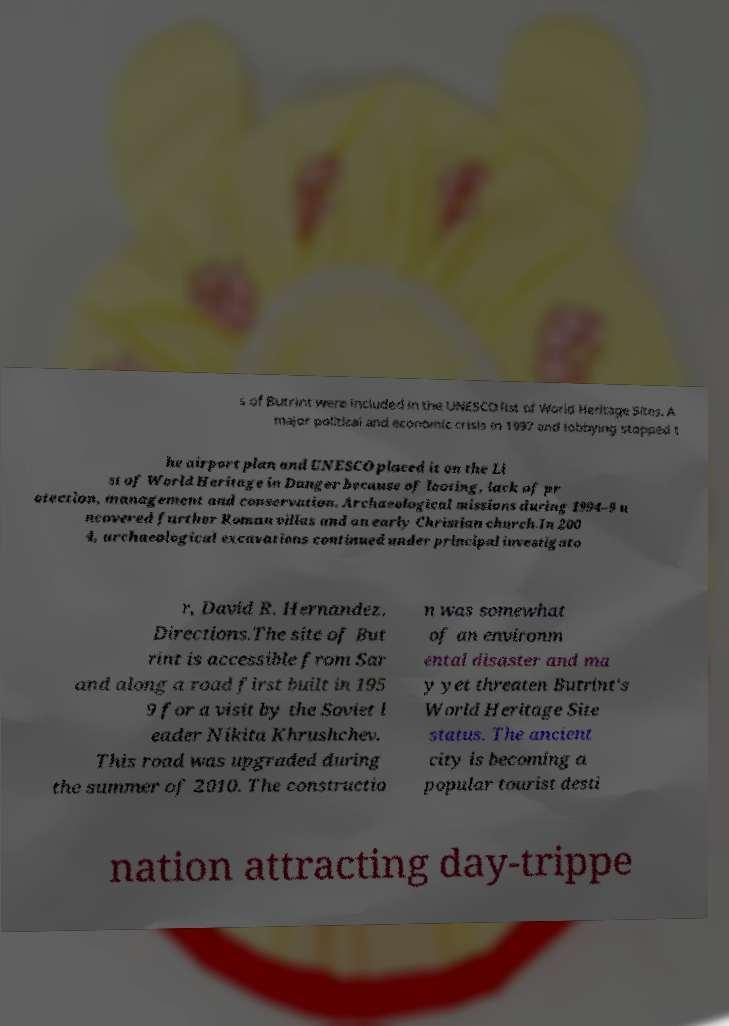For documentation purposes, I need the text within this image transcribed. Could you provide that? s of Butrint were included in the UNESCO list of World Heritage Sites. A major political and economic crisis in 1997 and lobbying stopped t he airport plan and UNESCO placed it on the Li st of World Heritage in Danger because of looting, lack of pr otection, management and conservation. Archaeological missions during 1994–9 u ncovered further Roman villas and an early Christian church.In 200 4, archaeological excavations continued under principal investigato r, David R. Hernandez. Directions.The site of But rint is accessible from Sar and along a road first built in 195 9 for a visit by the Soviet l eader Nikita Khrushchev. This road was upgraded during the summer of 2010. The constructio n was somewhat of an environm ental disaster and ma y yet threaten Butrint's World Heritage Site status. The ancient city is becoming a popular tourist desti nation attracting day-trippe 